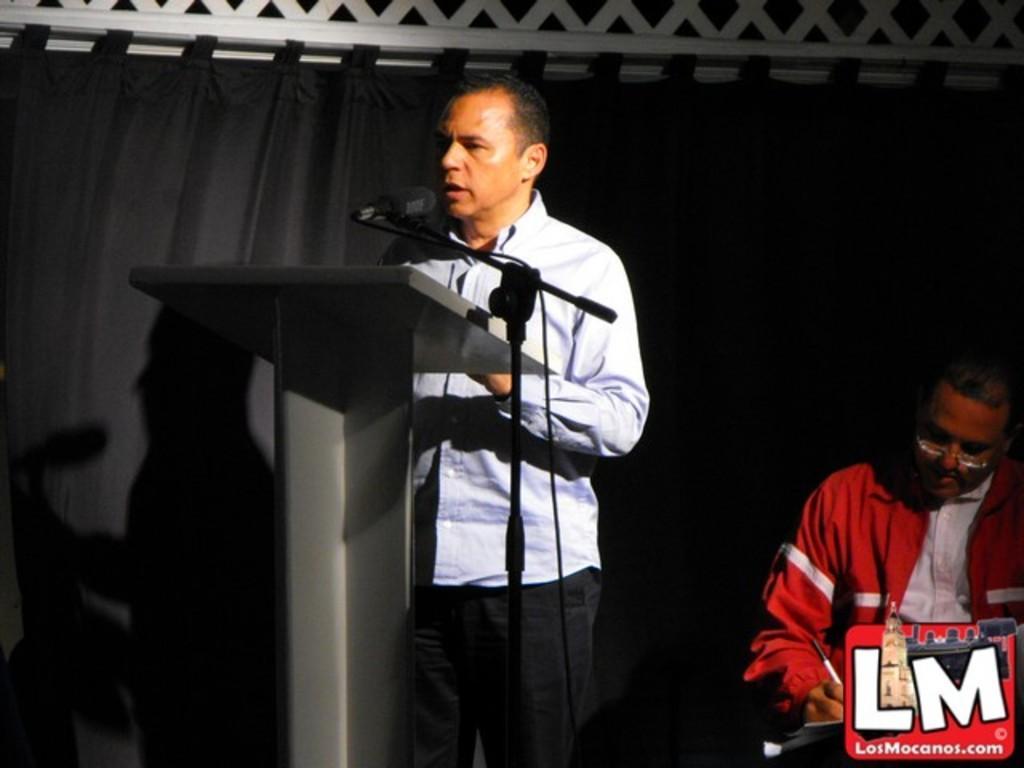Can you describe this image briefly? A man is standing near the podium and speaking in the microphone, he wore shirt, trouser. On the right side a man is sitting and writing, this man wore red color coat. 